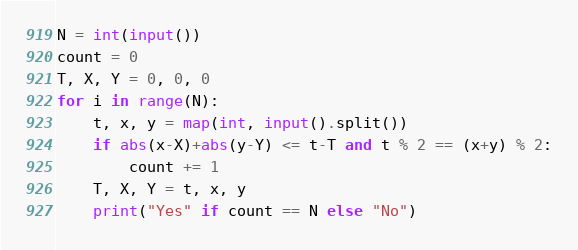<code> <loc_0><loc_0><loc_500><loc_500><_Python_>N = int(input())
count = 0
T, X, Y = 0, 0, 0
for i in range(N):
    t, x, y = map(int, input().split())
    if abs(x-X)+abs(y-Y) <= t-T and t % 2 == (x+y) % 2:
        count += 1
    T, X, Y = t, x, y
    print("Yes" if count == N else "No")</code> 